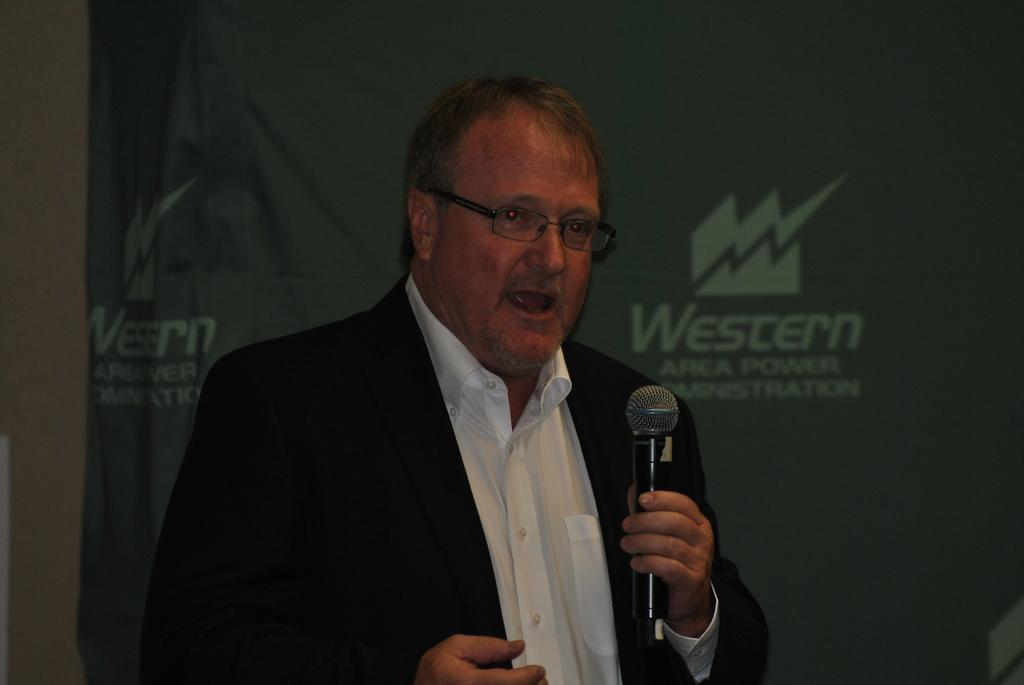Who is present in the image? There is a man in the image. What is the man wearing that is related to his eyes? The man is wearing glasses (specs) in the image. What object is the man holding in his hand? The man is holding a microphone (mic in the image. What type of industry can be seen in the background of the image? There is no industry visible in the image; it only shows a man wearing glasses and holding a microphone. 